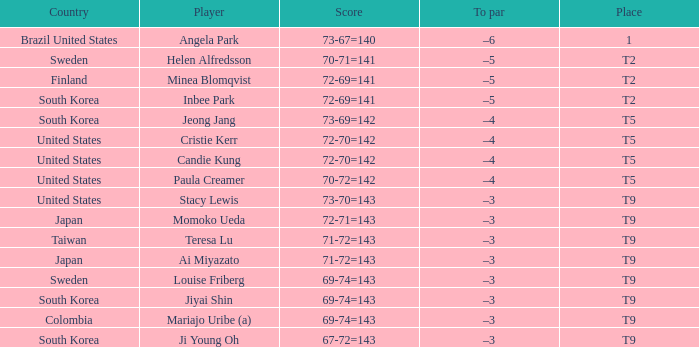What was Momoko Ueda's place? T9. 